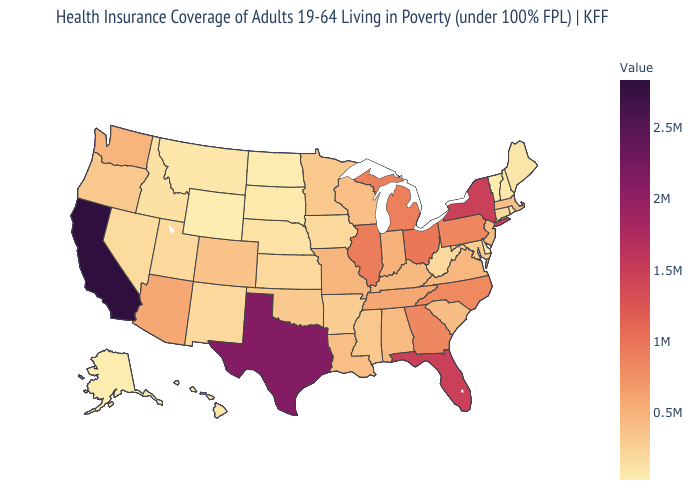Among the states that border Delaware , which have the highest value?
Give a very brief answer. Pennsylvania. Is the legend a continuous bar?
Concise answer only. Yes. Which states have the lowest value in the USA?
Short answer required. Wyoming. Among the states that border Nebraska , does Wyoming have the lowest value?
Write a very short answer. Yes. 